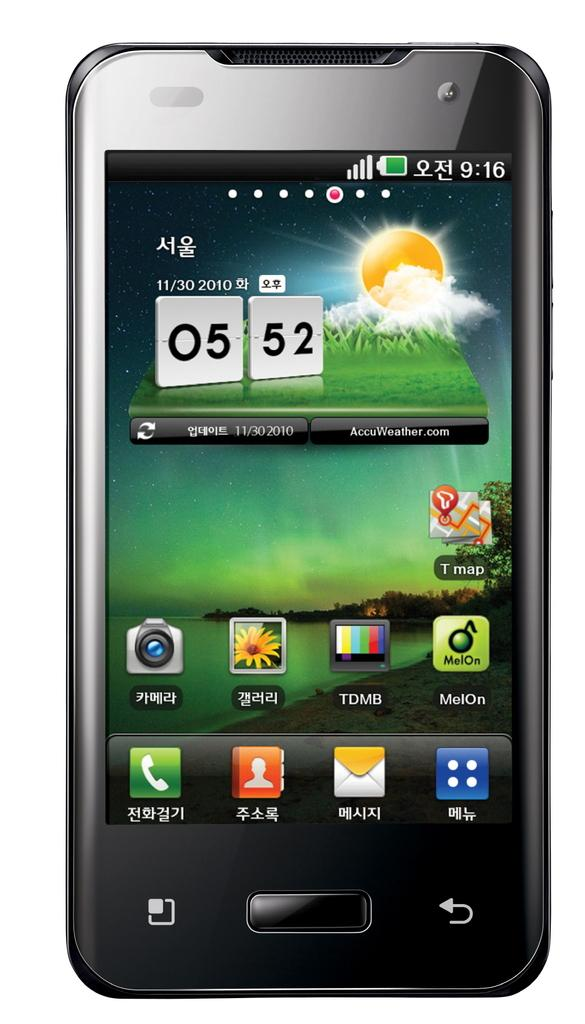<image>
Provide a brief description of the given image. A smartphone screen that says the time is 5:52. 